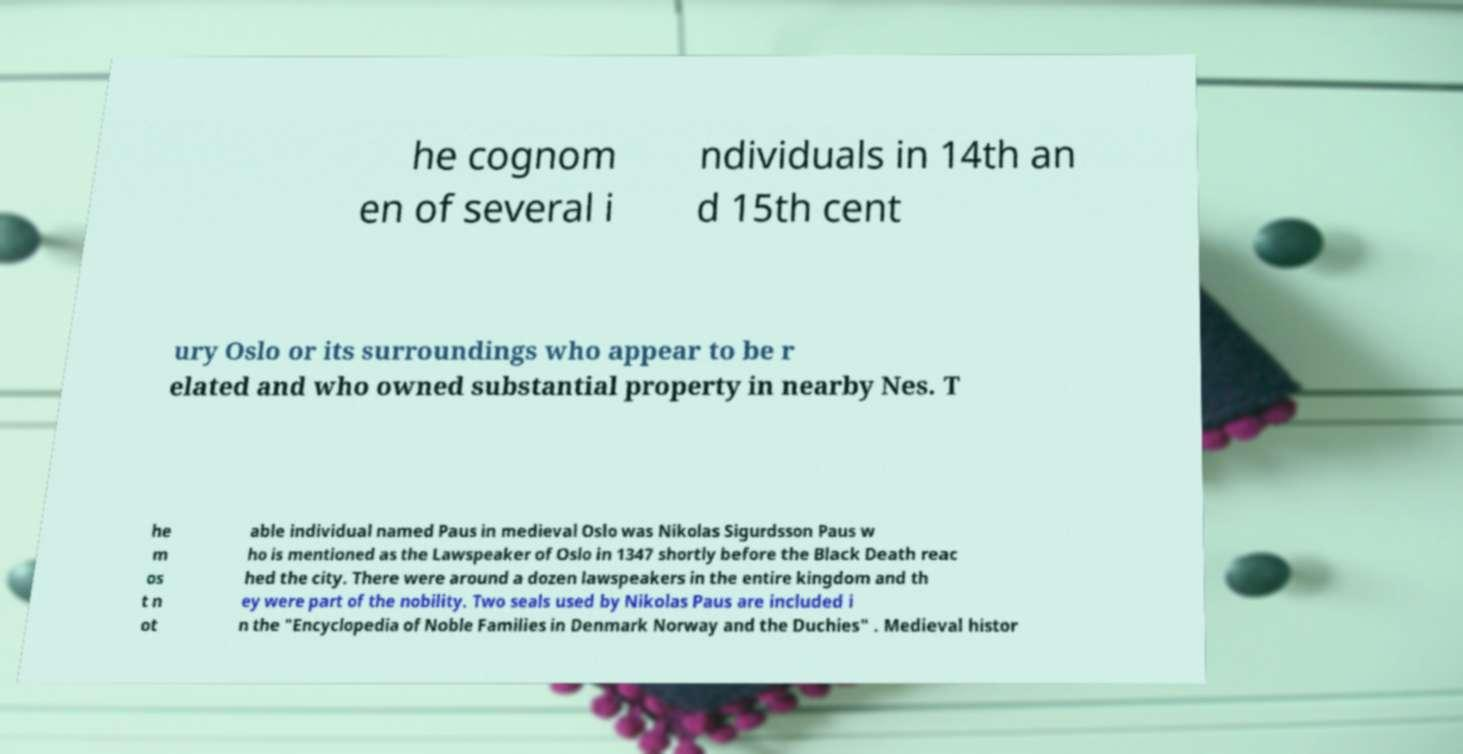For documentation purposes, I need the text within this image transcribed. Could you provide that? he cognom en of several i ndividuals in 14th an d 15th cent ury Oslo or its surroundings who appear to be r elated and who owned substantial property in nearby Nes. T he m os t n ot able individual named Paus in medieval Oslo was Nikolas Sigurdsson Paus w ho is mentioned as the Lawspeaker of Oslo in 1347 shortly before the Black Death reac hed the city. There were around a dozen lawspeakers in the entire kingdom and th ey were part of the nobility. Two seals used by Nikolas Paus are included i n the "Encyclopedia of Noble Families in Denmark Norway and the Duchies" . Medieval histor 